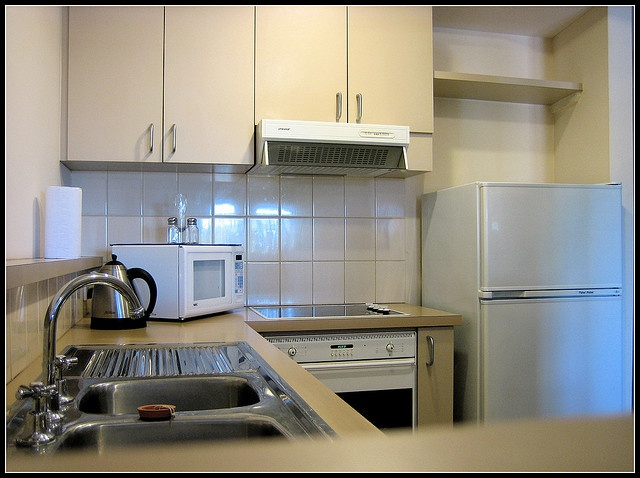Describe the objects in this image and their specific colors. I can see refrigerator in black, darkgray, lightblue, and gray tones, oven in black, darkgray, and gray tones, sink in black and gray tones, microwave in black, darkgray, and lightgray tones, and sink in black and gray tones in this image. 